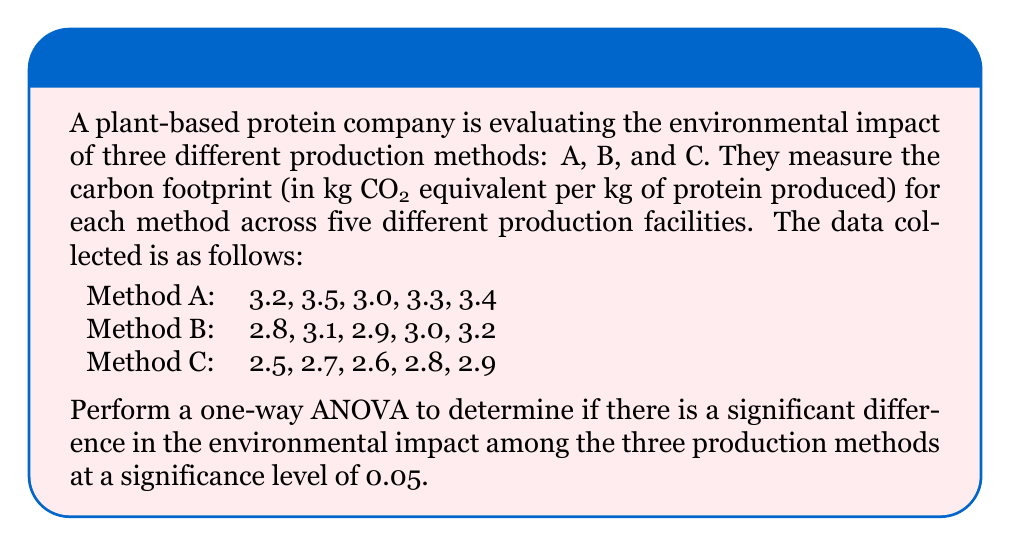Solve this math problem. To perform a one-way ANOVA, we need to follow these steps:

1. Calculate the sum of squares between groups (SSB), sum of squares within groups (SSW), and total sum of squares (SST).

2. Calculate the degrees of freedom for between groups (dfB), within groups (dfW), and total (dfT).

3. Calculate the mean square between groups (MSB) and mean square within groups (MSW).

4. Calculate the F-statistic.

5. Compare the F-statistic with the critical F-value to make a decision.

Step 1: Calculate sum of squares

First, we need to calculate the grand mean:
$$ \bar{X} = \frac{3.2 + 3.5 + 3.0 + 3.3 + 3.4 + 2.8 + 3.1 + 2.9 + 3.0 + 3.2 + 2.5 + 2.7 + 2.6 + 2.8 + 2.9}{15} = 3.06 $$

Now, we calculate the sum of squares between groups (SSB):
$$ SSB = 5[(3.28 - 3.06)^2 + (3.00 - 3.06)^2 + (2.70 - 3.06)^2] = 0.8440 $$

For the sum of squares within groups (SSW), we calculate:
$$ SSW = [(3.2 - 3.28)^2 + (3.5 - 3.28)^2 + (3.0 - 3.28)^2 + (3.3 - 3.28)^2 + (3.4 - 3.28)^2] + $$
$$ [(2.8 - 3.00)^2 + (3.1 - 3.00)^2 + (2.9 - 3.00)^2 + (3.0 - 3.00)^2 + (3.2 - 3.00)^2] + $$
$$ [(2.5 - 2.70)^2 + (2.7 - 2.70)^2 + (2.6 - 2.70)^2 + (2.8 - 2.70)^2 + (2.9 - 2.70)^2] = 0.2600 $$

The total sum of squares (SST) is:
$$ SST = SSB + SSW = 0.8440 + 0.2600 = 1.1040 $$

Step 2: Calculate degrees of freedom

dfB = number of groups - 1 = 3 - 1 = 2
dfW = total number of observations - number of groups = 15 - 3 = 12
dfT = total number of observations - 1 = 15 - 1 = 14

Step 3: Calculate mean squares

$$ MSB = \frac{SSB}{dfB} = \frac{0.8440}{2} = 0.4220 $$
$$ MSW = \frac{SSW}{dfW} = \frac{0.2600}{12} = 0.0217 $$

Step 4: Calculate F-statistic

$$ F = \frac{MSB}{MSW} = \frac{0.4220}{0.0217} = 19.4470 $$

Step 5: Compare F-statistic with critical F-value

The critical F-value for α = 0.05, dfB = 2, and dfW = 12 is approximately 3.89 (from F-distribution table).

Since our calculated F-statistic (19.4470) is greater than the critical F-value (3.89), we reject the null hypothesis.
Answer: The one-way ANOVA results show a significant difference in the environmental impact among the three production methods (F(2,12) = 19.4470, p < 0.05). We reject the null hypothesis and conclude that at least one of the production methods has a significantly different environmental impact compared to the others. 